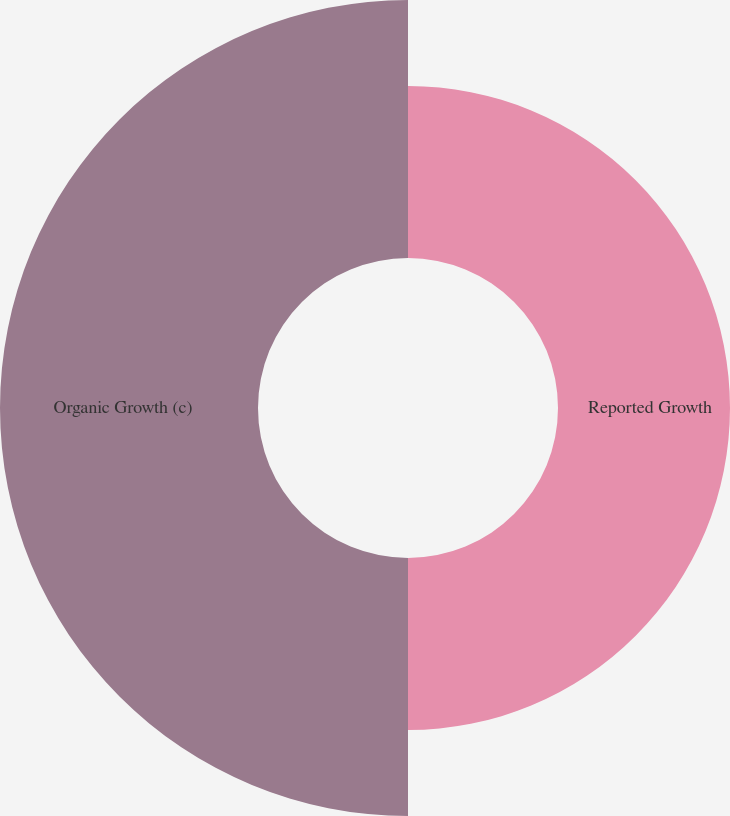Convert chart. <chart><loc_0><loc_0><loc_500><loc_500><pie_chart><fcel>Reported Growth<fcel>Organic Growth (c)<nl><fcel>40.0%<fcel>60.0%<nl></chart> 